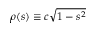Convert formula to latex. <formula><loc_0><loc_0><loc_500><loc_500>\rho ( s ) \equiv c \sqrt { 1 - s ^ { 2 } }</formula> 